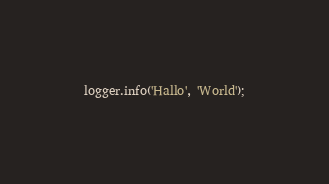Convert code to text. <code><loc_0><loc_0><loc_500><loc_500><_TypeScript_>logger.info('Hallo', 'World');
</code> 